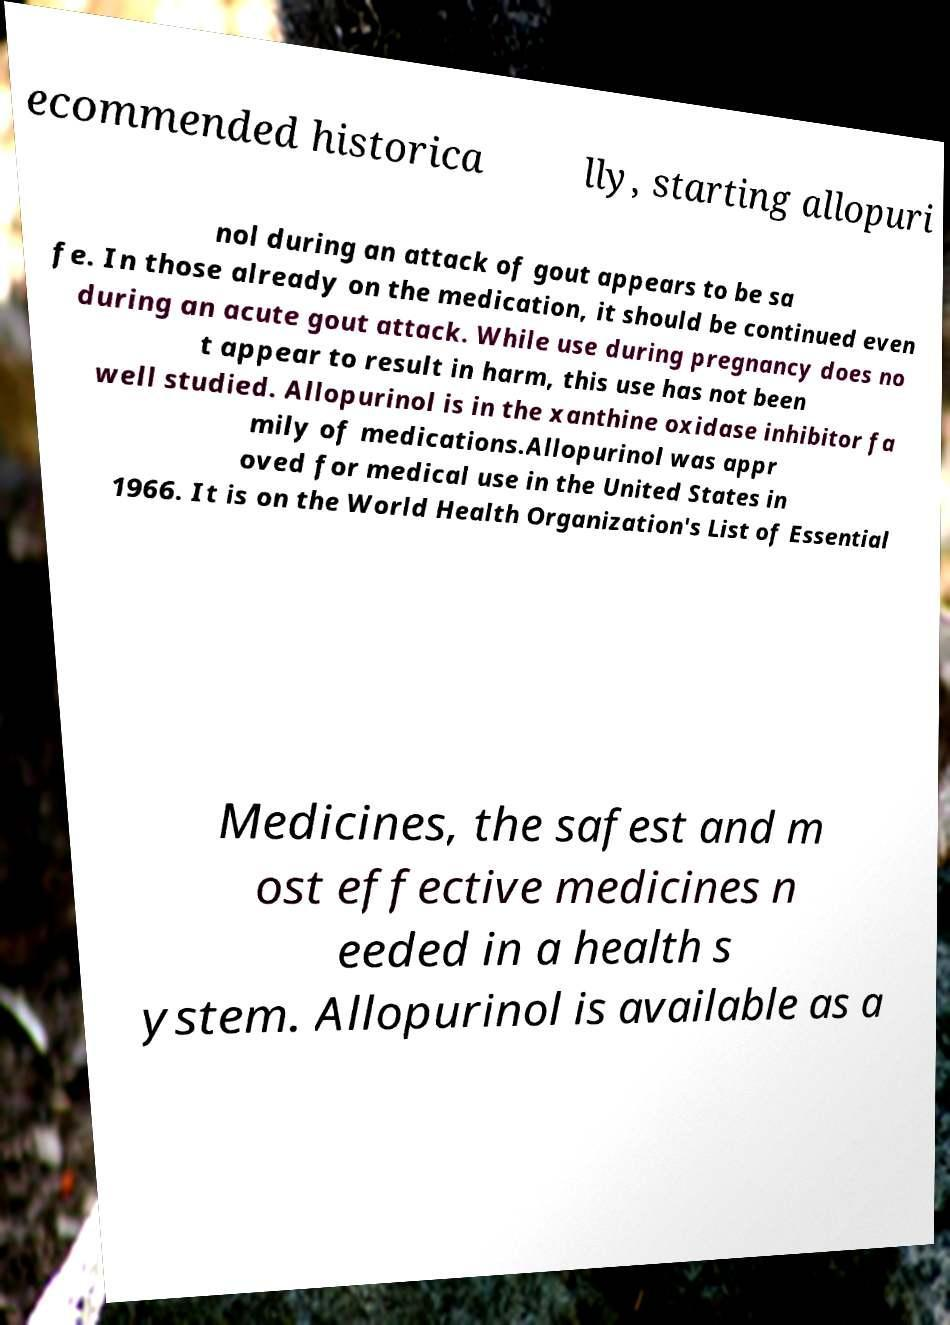Could you assist in decoding the text presented in this image and type it out clearly? ecommended historica lly, starting allopuri nol during an attack of gout appears to be sa fe. In those already on the medication, it should be continued even during an acute gout attack. While use during pregnancy does no t appear to result in harm, this use has not been well studied. Allopurinol is in the xanthine oxidase inhibitor fa mily of medications.Allopurinol was appr oved for medical use in the United States in 1966. It is on the World Health Organization's List of Essential Medicines, the safest and m ost effective medicines n eeded in a health s ystem. Allopurinol is available as a 